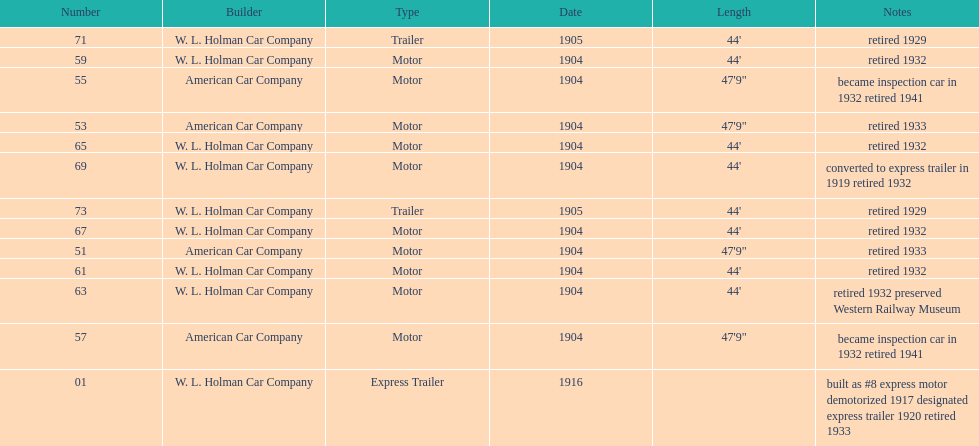Did american car company or w.l. holman car company build cars that were 44' in length? W. L. Holman Car Company. 